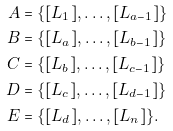Convert formula to latex. <formula><loc_0><loc_0><loc_500><loc_500>A & = \{ [ L _ { 1 } ] , \dots , [ L _ { a - 1 } ] \} \\ B & = \{ [ L _ { a } ] , \dots , [ L _ { b - 1 } ] \} \\ C & = \{ [ L _ { b } ] , \dots , [ L _ { c - 1 } ] \} \\ D & = \{ [ L _ { c } ] , \dots , [ L _ { d - 1 } ] \} \\ E & = \{ [ L _ { d } ] , \dots , [ L _ { n } ] \} .</formula> 